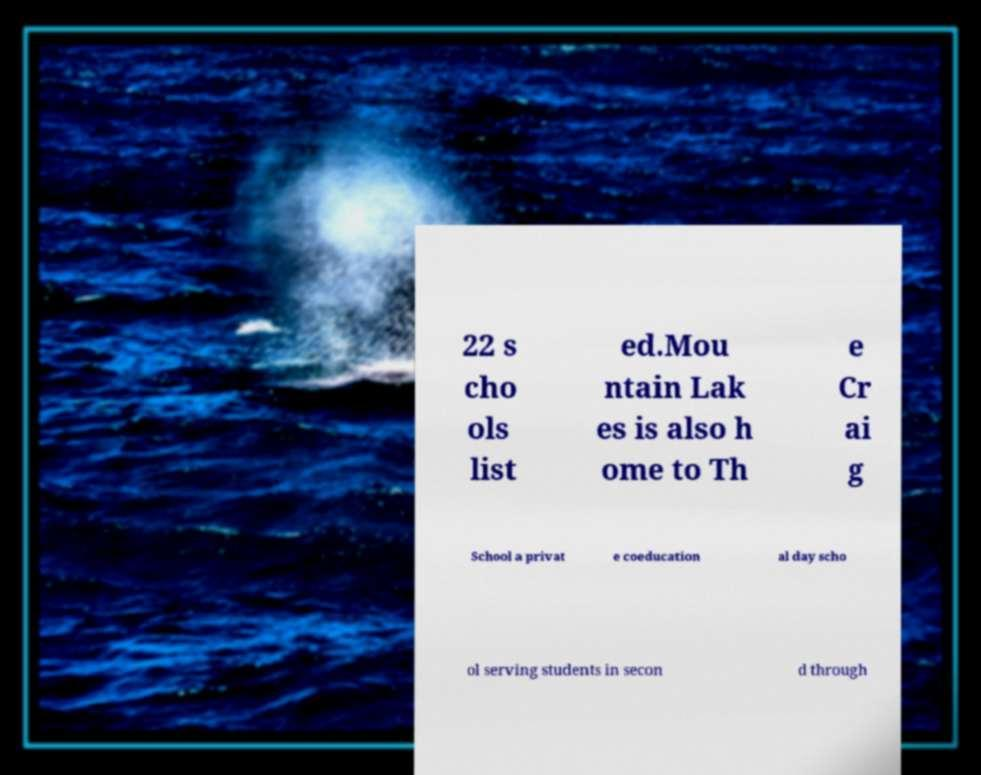Can you read and provide the text displayed in the image?This photo seems to have some interesting text. Can you extract and type it out for me? 22 s cho ols list ed.Mou ntain Lak es is also h ome to Th e Cr ai g School a privat e coeducation al day scho ol serving students in secon d through 